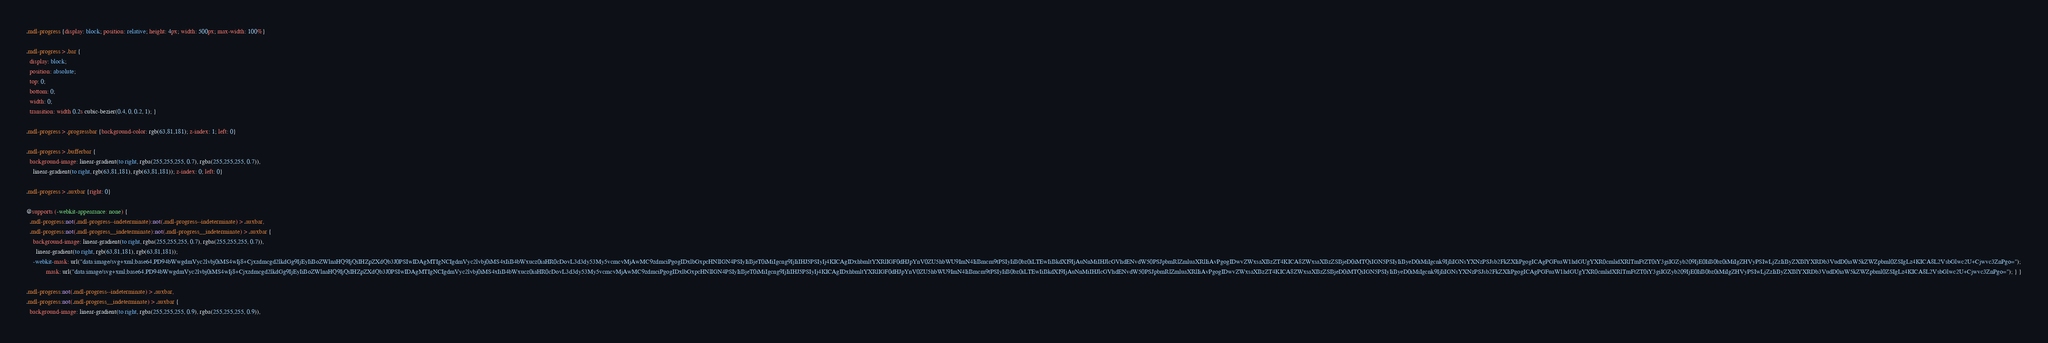Convert code to text. <code><loc_0><loc_0><loc_500><loc_500><_CSS_>.mdl-progress {display: block; position: relative; height: 4px; width: 500px; max-width: 100%}

.mdl-progress > .bar {
  display: block;
  position: absolute;
  top: 0;
  bottom: 0;
  width: 0;
  transition: width 0.2s cubic-bezier(0.4, 0, 0.2, 1); }

.mdl-progress > .progressbar {background-color: rgb(63,81,181); z-index: 1; left: 0}

.mdl-progress > .bufferbar {
  background-image: linear-gradient(to right, rgba(255,255,255, 0.7), rgba(255,255,255, 0.7)),
    linear-gradient(to right, rgb(63,81,181), rgb(63,81,181)); z-index: 0; left: 0}

.mdl-progress > .auxbar {right: 0}

@supports (-webkit-appearance: none) {
  .mdl-progress:not(.mdl-progress--indeterminate):not(.mdl-progress--indeterminate) > .auxbar,
  .mdl-progress:not(.mdl-progress__indeterminate):not(.mdl-progress__indeterminate) > .auxbar {
    background-image: linear-gradient(to right, rgba(255,255,255, 0.7), rgba(255,255,255, 0.7)),
      linear-gradient(to right, rgb(63,81,181), rgb(63,81,181));
    -webkit-mask: url("data:image/svg+xml;base64,PD94bWwgdmVyc2lvbj0iMS4wIj8+Cjxzdmcgd2lkdGg9IjEyIiBoZWlnaHQ9IjQiIHZpZXdQb3J0PSIwIDAgMTIgNCIgdmVyc2lvbj0iMS4xIiB4bWxucz0iaHR0cDovL3d3dy53My5vcmcvMjAwMC9zdmciPgogIDxlbGxpcHNlIGN4PSIyIiBjeT0iMiIgcng9IjIiIHJ5PSIyIj4KICAgIDxhbmltYXRlIGF0dHJpYnV0ZU5hbWU9ImN4IiBmcm9tPSIyIiB0bz0iLTEwIiBkdXI9IjAuNnMiIHJlcGVhdENvdW50PSJpbmRlZmluaXRlIiAvPgogIDwvZWxsaXBzZT4KICA8ZWxsaXBzZSBjeD0iMTQiIGN5PSIyIiByeD0iMiIgcnk9IjIiIGNsYXNzPSJsb2FkZXIiPgogICAgPGFuaW1hdGUgYXR0cmlidXRlTmFtZT0iY3giIGZyb209IjE0IiB0bz0iMiIgZHVyPSIwLjZzIiByZXBlYXRDb3VudD0iaW5kZWZpbml0ZSIgLz4KICA8L2VsbGlwc2U+Cjwvc3ZnPgo=");
            mask: url("data:image/svg+xml;base64,PD94bWwgdmVyc2lvbj0iMS4wIj8+Cjxzdmcgd2lkdGg9IjEyIiBoZWlnaHQ9IjQiIHZpZXdQb3J0PSIwIDAgMTIgNCIgdmVyc2lvbj0iMS4xIiB4bWxucz0iaHR0cDovL3d3dy53My5vcmcvMjAwMC9zdmciPgogIDxlbGxpcHNlIGN4PSIyIiBjeT0iMiIgcng9IjIiIHJ5PSIyIj4KICAgIDxhbmltYXRlIGF0dHJpYnV0ZU5hbWU9ImN4IiBmcm9tPSIyIiB0bz0iLTEwIiBkdXI9IjAuNnMiIHJlcGVhdENvdW50PSJpbmRlZmluaXRlIiAvPgogIDwvZWxsaXBzZT4KICA8ZWxsaXBzZSBjeD0iMTQiIGN5PSIyIiByeD0iMiIgcnk9IjIiIGNsYXNzPSJsb2FkZXIiPgogICAgPGFuaW1hdGUgYXR0cmlidXRlTmFtZT0iY3giIGZyb209IjE0IiB0bz0iMiIgZHVyPSIwLjZzIiByZXBlYXRDb3VudD0iaW5kZWZpbml0ZSIgLz4KICA8L2VsbGlwc2U+Cjwvc3ZnPgo="); } }

.mdl-progress:not(.mdl-progress--indeterminate) > .auxbar,
.mdl-progress:not(.mdl-progress__indeterminate) > .auxbar {
  background-image: linear-gradient(to right, rgba(255,255,255, 0.9), rgba(255,255,255, 0.9)),</code> 